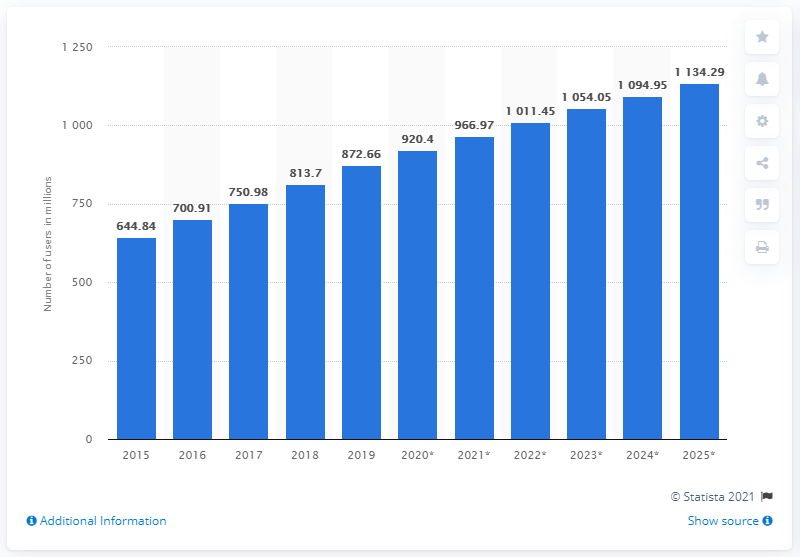Outline some significant characteristics in this image. In 2019, 872,668,000 people in China accessed the internet through their mobile phones. 